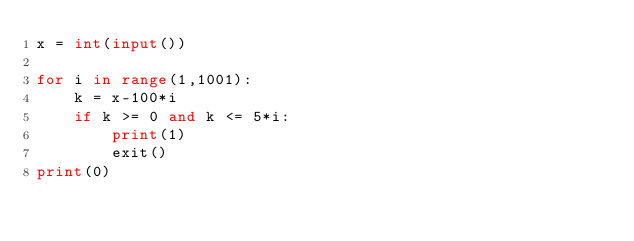<code> <loc_0><loc_0><loc_500><loc_500><_Python_>x = int(input())

for i in range(1,1001):
    k = x-100*i
    if k >= 0 and k <= 5*i:
        print(1)
        exit()
print(0)</code> 